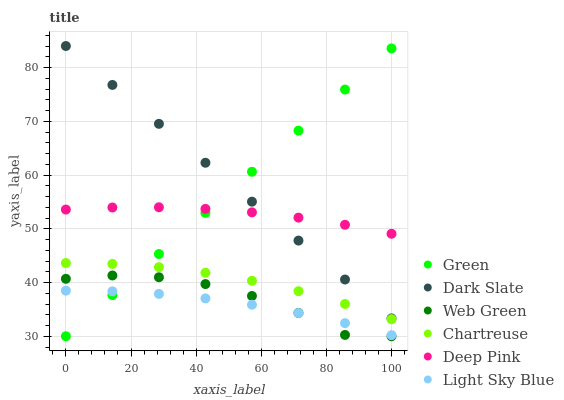Does Light Sky Blue have the minimum area under the curve?
Answer yes or no. Yes. Does Dark Slate have the maximum area under the curve?
Answer yes or no. Yes. Does Web Green have the minimum area under the curve?
Answer yes or no. No. Does Web Green have the maximum area under the curve?
Answer yes or no. No. Is Green the smoothest?
Answer yes or no. Yes. Is Web Green the roughest?
Answer yes or no. Yes. Is Dark Slate the smoothest?
Answer yes or no. No. Is Dark Slate the roughest?
Answer yes or no. No. Does Web Green have the lowest value?
Answer yes or no. Yes. Does Dark Slate have the lowest value?
Answer yes or no. No. Does Dark Slate have the highest value?
Answer yes or no. Yes. Does Web Green have the highest value?
Answer yes or no. No. Is Web Green less than Dark Slate?
Answer yes or no. Yes. Is Deep Pink greater than Light Sky Blue?
Answer yes or no. Yes. Does Dark Slate intersect Green?
Answer yes or no. Yes. Is Dark Slate less than Green?
Answer yes or no. No. Is Dark Slate greater than Green?
Answer yes or no. No. Does Web Green intersect Dark Slate?
Answer yes or no. No. 